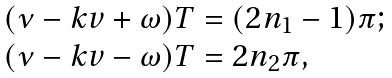Convert formula to latex. <formula><loc_0><loc_0><loc_500><loc_500>\begin{array} { l } ( \nu - k v + \omega ) T = ( 2 n _ { 1 } - 1 ) \pi ; \\ ( \nu - k v - \omega ) T = 2 n _ { 2 } \pi , \end{array}</formula> 